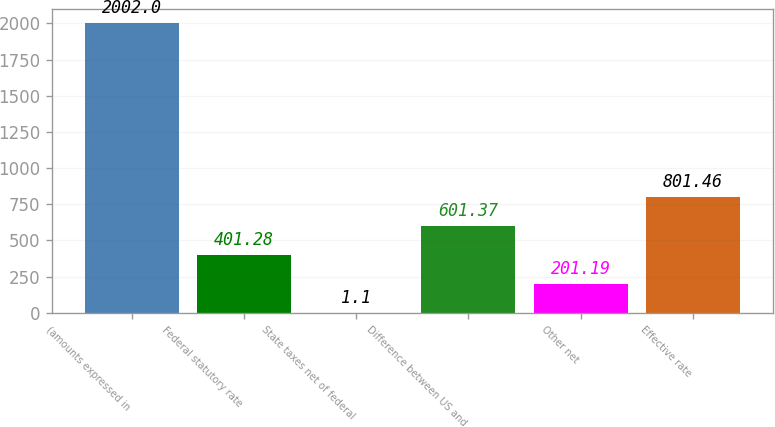Convert chart to OTSL. <chart><loc_0><loc_0><loc_500><loc_500><bar_chart><fcel>(amounts expressed in<fcel>Federal statutory rate<fcel>State taxes net of federal<fcel>Difference between US and<fcel>Other net<fcel>Effective rate<nl><fcel>2002<fcel>401.28<fcel>1.1<fcel>601.37<fcel>201.19<fcel>801.46<nl></chart> 